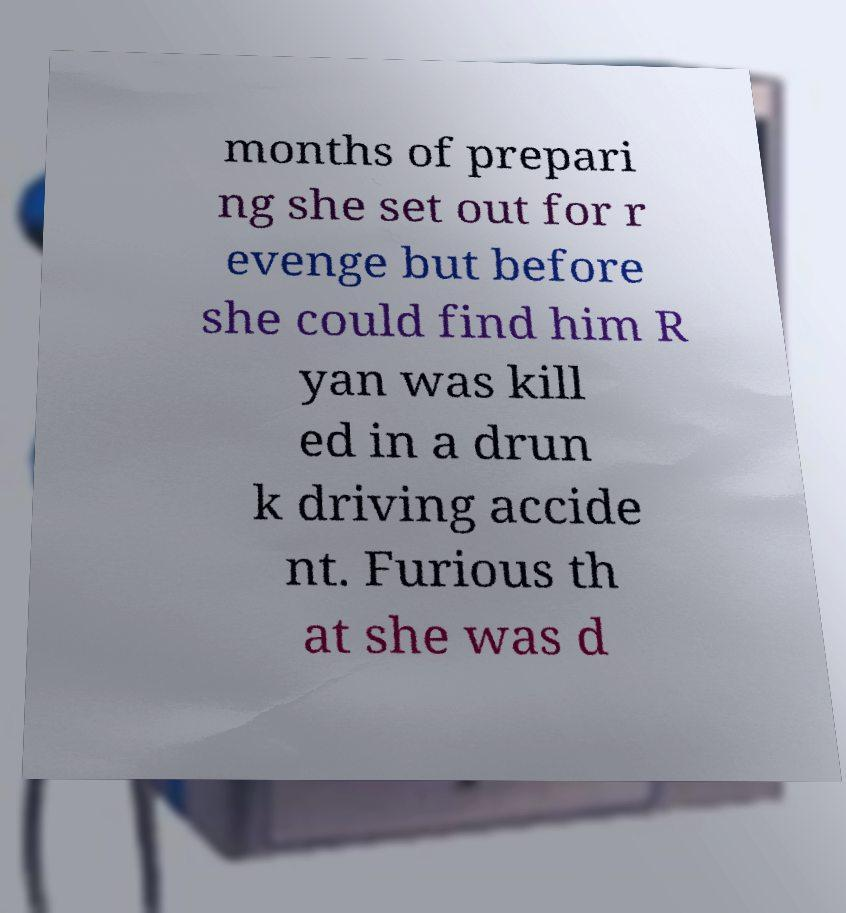Please read and relay the text visible in this image. What does it say? months of prepari ng she set out for r evenge but before she could find him R yan was kill ed in a drun k driving accide nt. Furious th at she was d 